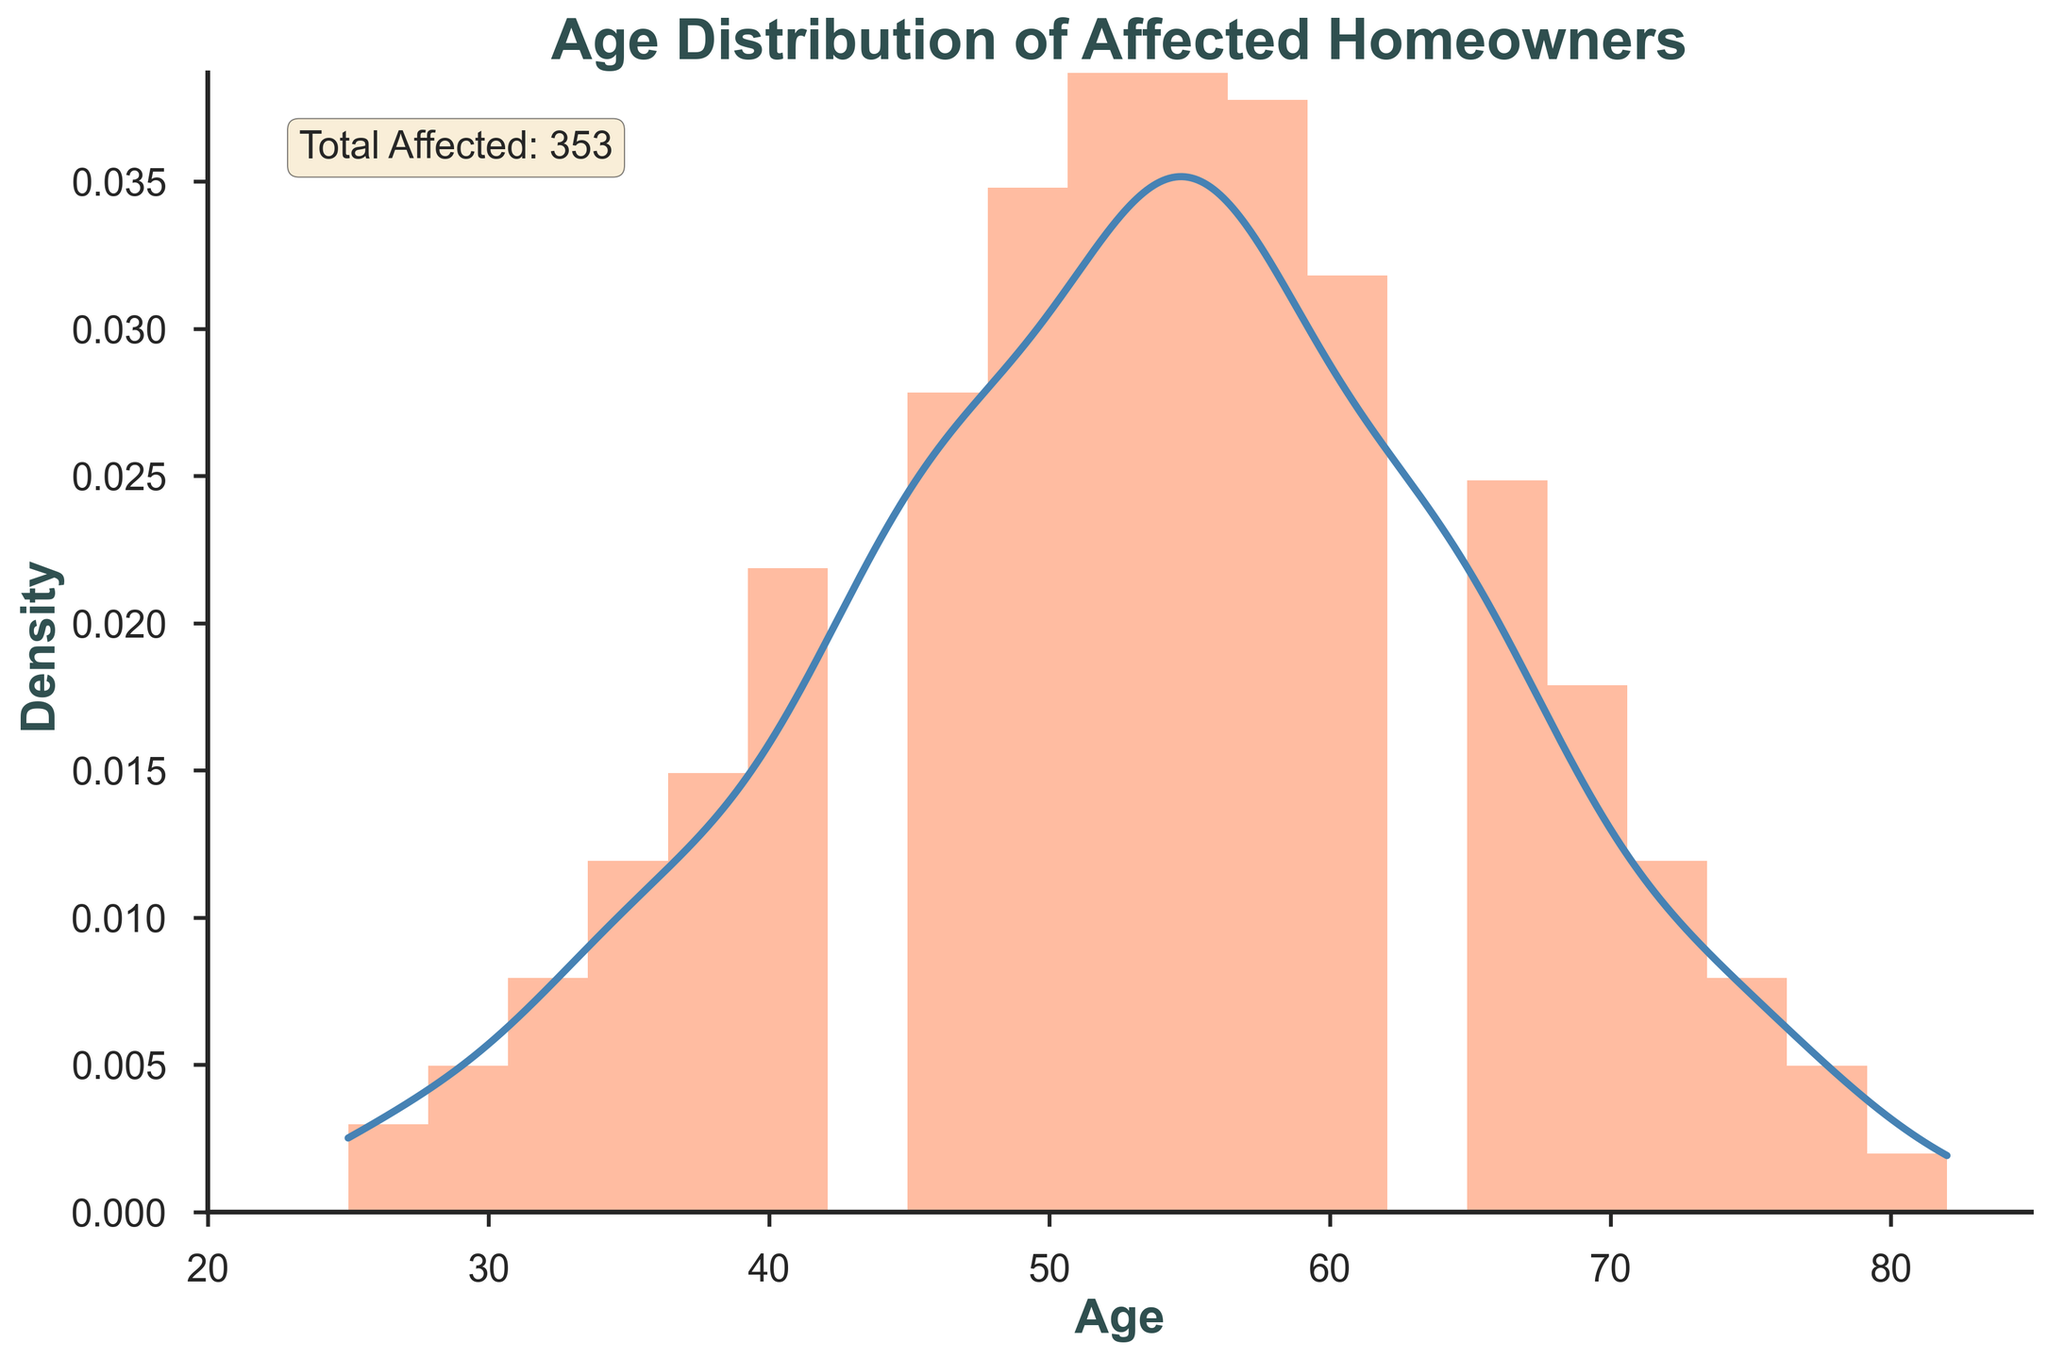What is the title of the plot? The title is prominently displayed at the top center of the plot.
Answer: Age Distribution of Affected Homeowners Which age group has the highest density? The density is represented by the KDE curve. The peak of the curve indicates the highest density.
Answer: Around age 55 How many homeowners are represented in the age group 42? The count for each age group is represented by the height of the bars in the histogram.
Answer: 22 What does the text box in the figure indicate? The text box inside the plot provides a summary of the total number of affected homeowners.
Answer: Total Affected: 385 Which age group has a higher density: 35 or 72? Comparing the heights of the KDE curve at ages 35 and 72 will show which age group has a higher density.
Answer: Age 35 What is the general trend in the age distribution of affected homeowners? Observing the overall shape of the histogram and KDE curve, we can see if there are any increasing or decreasing patterns.
Answer: Increases until 55, then decreases How does the density of homeowners aged 48 compare to those aged 68? By comparing the KDE curve heights at ages 48 and 68, we can determine which age group has higher density.
Answer: Age 48 has higher density What is the density value at age 50 approximately? By examining the KDE curve at age 50, we can approximate the density value.
Answer: Approximately 0.027 Is there a significant number of homeowners older than 75? Observing the histogram bars and KDE curve beyond age 75 helps determine if there are many such homeowners.
Answer: No, the numbers decrease significantly Can you identify an age range where the number of affected homeowners decreases? Looking at both the histogram and KDE curve, we identify where the count and density decline.
Answer: Ages 55 to 82 